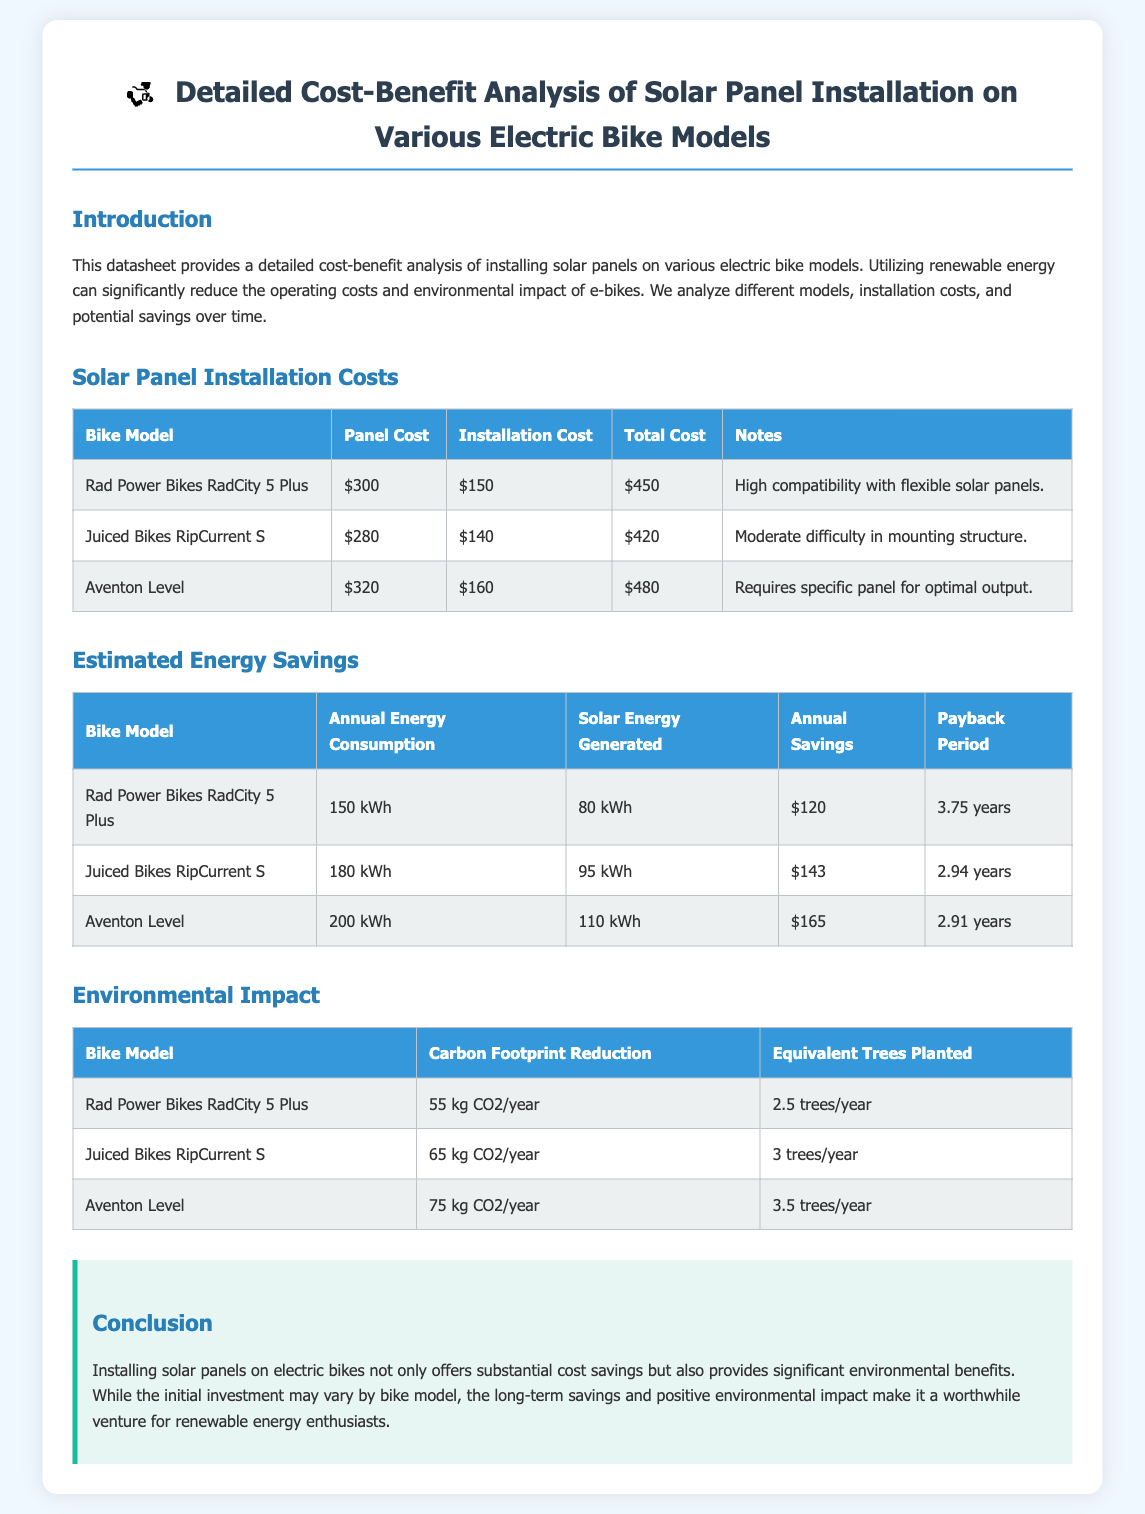What is the total cost of the Rad Power Bikes RadCity 5 Plus? The total cost is listed in the Solar Panel Installation Costs table for the Rad Power Bikes RadCity 5 Plus, which is $450.
Answer: $450 How much solar energy does the Juiced Bikes RipCurrent S generate annually? The solar energy generated is provided in the Estimated Energy Savings table for the Juiced Bikes RipCurrent S, which is 95 kWh.
Answer: 95 kWh What is the payback period for the Aventon Level? The payback period is mentioned in the Estimated Energy Savings table, which states it is 2.91 years for the Aventon Level.
Answer: 2.91 years What is the carbon footprint reduction for the Rad Power Bikes RadCity 5 Plus? The carbon footprint reduction is listed in the Environmental Impact table for the Rad Power Bikes RadCity 5 Plus, which is 55 kg CO2/year.
Answer: 55 kg CO2/year Which bike model has the highest annual savings? The annual savings can be compared in the Estimated Energy Savings table; the Aventon Level has the highest at $165.
Answer: $165 What are the installation costs for the Juiced Bikes RipCurrent S? The installation costs are specified in the Solar Panel Installation Costs table for the Juiced Bikes RipCurrent S, which is $140.
Answer: $140 How many equivalent trees planted are associated with the Aventon Level? The equivalent trees planted are provided in the Environmental Impact table for the Aventon Level, which is 3.5 trees/year.
Answer: 3.5 trees/year What is the note regarding the Rad Power Bikes RadCity 5 Plus? The note is included in the Solar Panel Installation Costs table, stating it has high compatibility with flexible solar panels.
Answer: High compatibility with flexible solar panels 